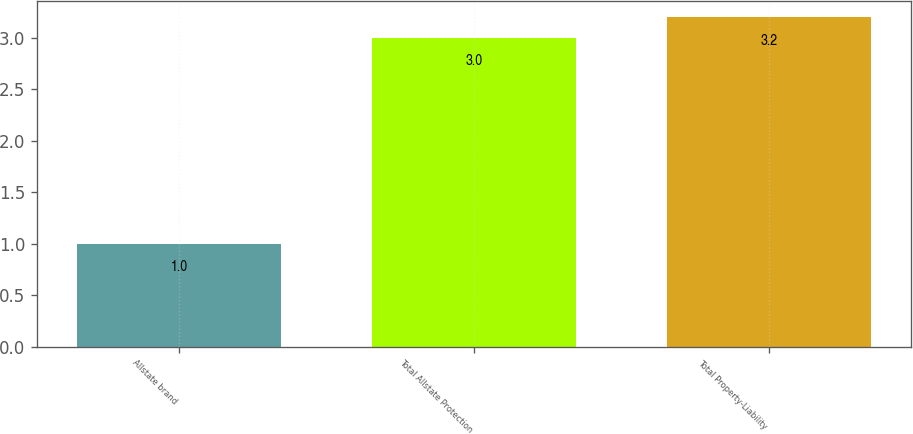Convert chart. <chart><loc_0><loc_0><loc_500><loc_500><bar_chart><fcel>Allstate brand<fcel>Total Allstate Protection<fcel>Total Property-Liability<nl><fcel>1<fcel>3<fcel>3.2<nl></chart> 